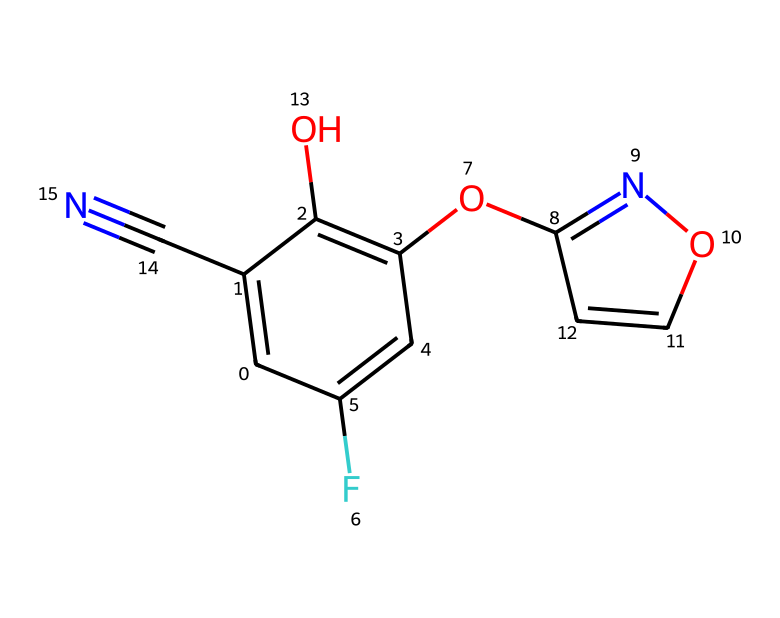What is the molecular formula of fludioxonil? To determine the molecular formula, we need to count the different types of atoms in the structure represented by the SMILES. The atoms present include: Carbon (C), Hydrogen (H), Fluorine (F), Nitrogen (N), and Oxygen (O). Counting these gives: C (11), H (8), F (1), N (3), and O (2), leading to the molecular formula C11H8F1N3O2.
Answer: C11H8F1N3O2 How many rings are present in the structure? By analyzing the SMILES, we identify two cyclic structures. The notation indicates a bicyclic structure where there are two distinct ring systems. This leads us to conclude that there are 2 rings overall in the molecule.
Answer: 2 What functional groups are present in fludioxonil? The chemical structure has multiple functional groups, including hydroxyl (-OH), a nitro group, and an ether linkage. Each functional group influences the chemical's reactivity and stability, so identifying these is essential for understanding its behavior as a fungicide.
Answer: hydroxyl, nitro, ether What is the significance of the cyano group in this chemical? The cyano group (-C#N) in the structure is crucial for the fungicidal activity of fludioxonil. It adds to the molecular polarity and contributes to the overall molecular geometry, which can enhance the compound's ability to interact with target organisms in post-harvest treatment.
Answer: fungicidal activity Which halogen is present in the chemical structure? In the provided SMILES representation, 'F' indicates the presence of fluorine as the halogen in the molecular structure. The presence of fluorine often alters the compound's lipophilicity and stability, contributing to its effectiveness as a fungicide.
Answer: fluorine 